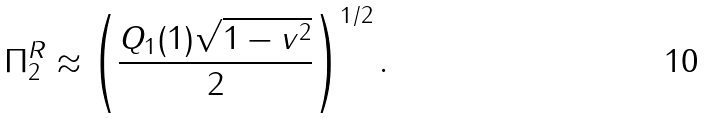<formula> <loc_0><loc_0><loc_500><loc_500>\Pi _ { 2 } ^ { R } \approx \left ( \frac { Q _ { 1 } ( 1 ) \sqrt { 1 - v ^ { 2 } } } { 2 } \right ) ^ { 1 / 2 } .</formula> 